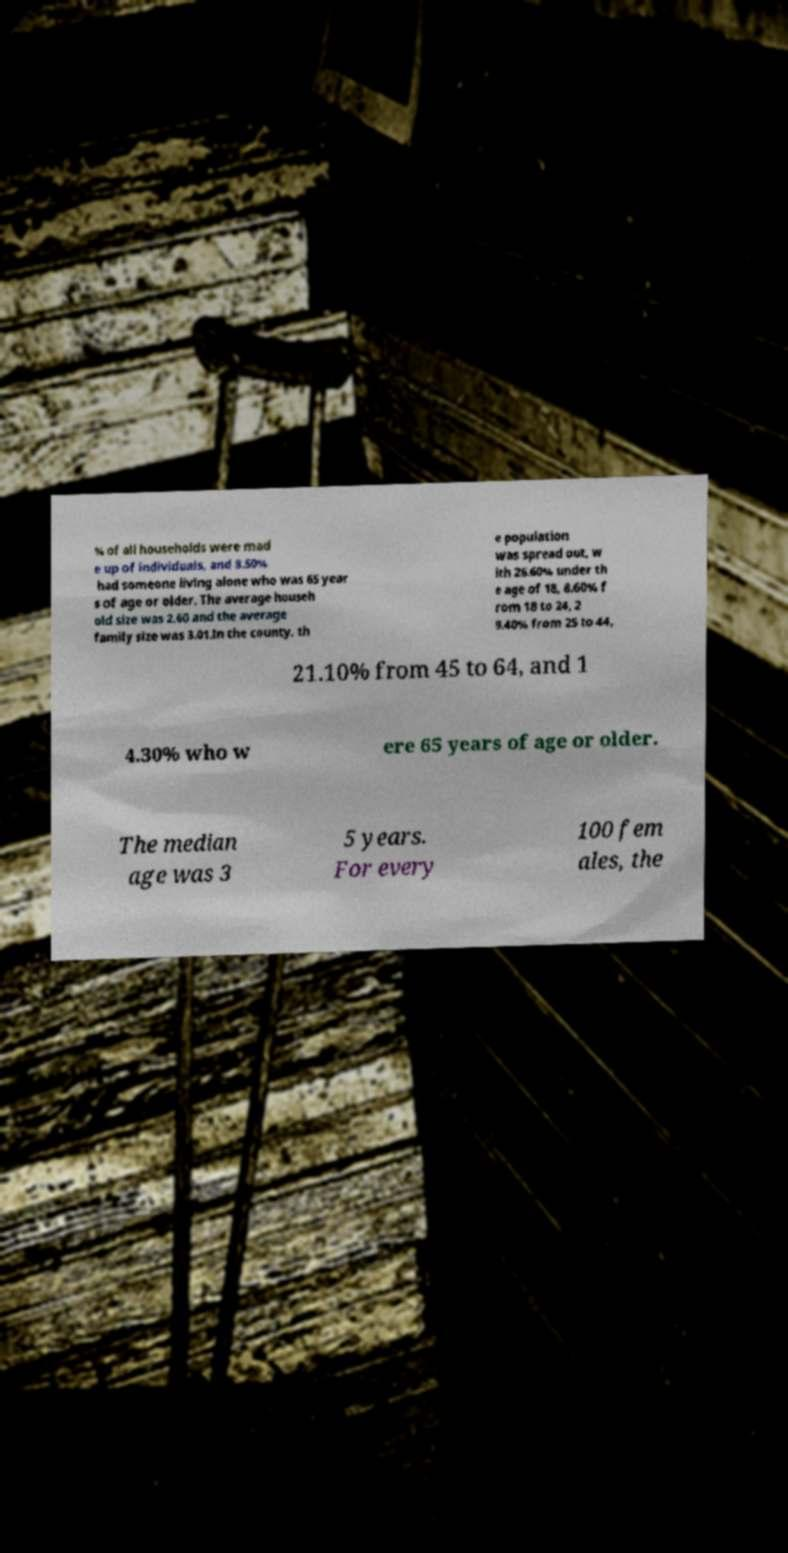Please read and relay the text visible in this image. What does it say? % of all households were mad e up of individuals, and 8.50% had someone living alone who was 65 year s of age or older. The average househ old size was 2.60 and the average family size was 3.01.In the county, th e population was spread out, w ith 26.60% under th e age of 18, 8.60% f rom 18 to 24, 2 9.40% from 25 to 44, 21.10% from 45 to 64, and 1 4.30% who w ere 65 years of age or older. The median age was 3 5 years. For every 100 fem ales, the 